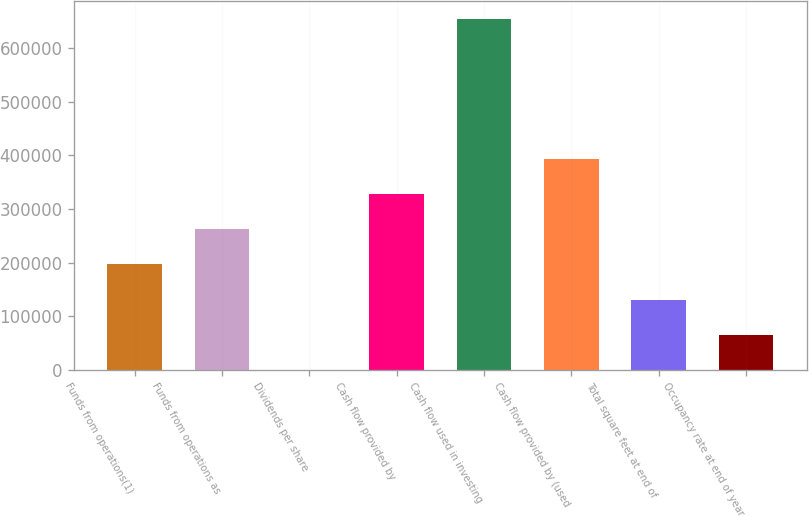Convert chart to OTSL. <chart><loc_0><loc_0><loc_500><loc_500><bar_chart><fcel>Funds from operations(1)<fcel>Funds from operations as<fcel>Dividends per share<fcel>Cash flow provided by<fcel>Cash flow used in investing<fcel>Cash flow provided by (used<fcel>Total square feet at end of<fcel>Occupancy rate at end of year<nl><fcel>196500<fcel>261999<fcel>1.75<fcel>327499<fcel>654996<fcel>392998<fcel>131001<fcel>65501.2<nl></chart> 